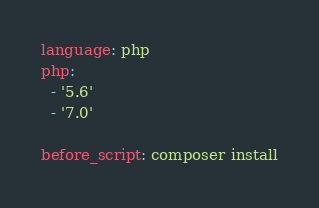Convert code to text. <code><loc_0><loc_0><loc_500><loc_500><_YAML_>language: php
php:
  - '5.6'
  - '7.0'

before_script: composer install

</code> 